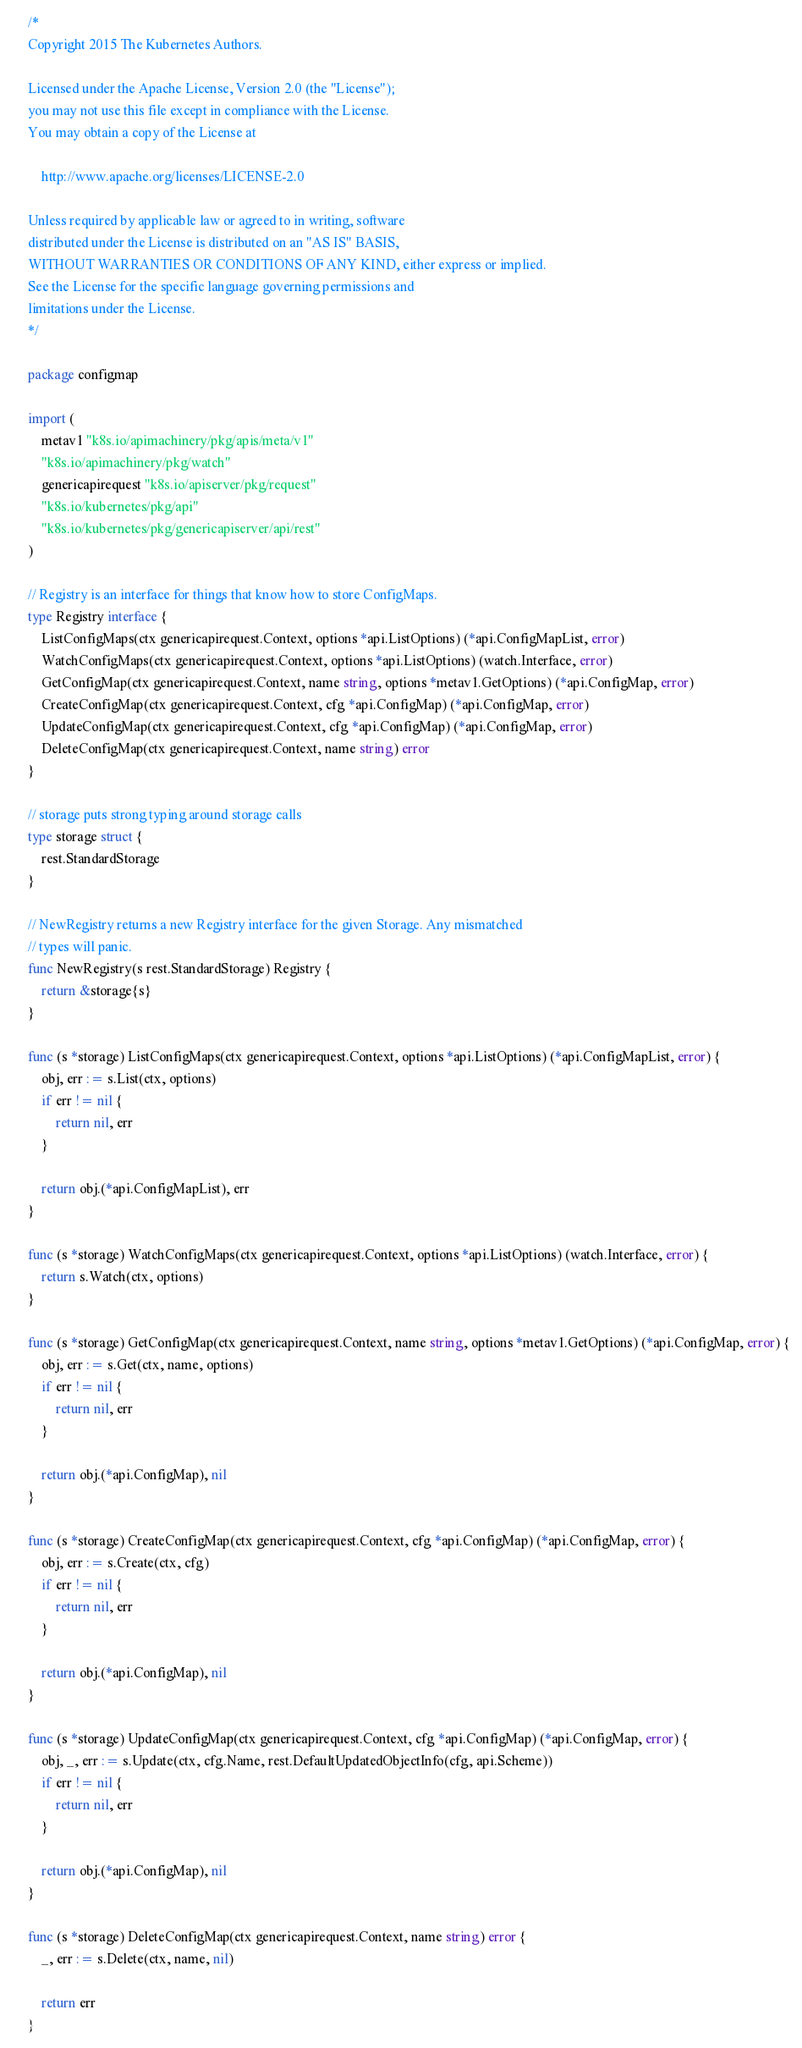Convert code to text. <code><loc_0><loc_0><loc_500><loc_500><_Go_>/*
Copyright 2015 The Kubernetes Authors.

Licensed under the Apache License, Version 2.0 (the "License");
you may not use this file except in compliance with the License.
You may obtain a copy of the License at

    http://www.apache.org/licenses/LICENSE-2.0

Unless required by applicable law or agreed to in writing, software
distributed under the License is distributed on an "AS IS" BASIS,
WITHOUT WARRANTIES OR CONDITIONS OF ANY KIND, either express or implied.
See the License for the specific language governing permissions and
limitations under the License.
*/

package configmap

import (
	metav1 "k8s.io/apimachinery/pkg/apis/meta/v1"
	"k8s.io/apimachinery/pkg/watch"
	genericapirequest "k8s.io/apiserver/pkg/request"
	"k8s.io/kubernetes/pkg/api"
	"k8s.io/kubernetes/pkg/genericapiserver/api/rest"
)

// Registry is an interface for things that know how to store ConfigMaps.
type Registry interface {
	ListConfigMaps(ctx genericapirequest.Context, options *api.ListOptions) (*api.ConfigMapList, error)
	WatchConfigMaps(ctx genericapirequest.Context, options *api.ListOptions) (watch.Interface, error)
	GetConfigMap(ctx genericapirequest.Context, name string, options *metav1.GetOptions) (*api.ConfigMap, error)
	CreateConfigMap(ctx genericapirequest.Context, cfg *api.ConfigMap) (*api.ConfigMap, error)
	UpdateConfigMap(ctx genericapirequest.Context, cfg *api.ConfigMap) (*api.ConfigMap, error)
	DeleteConfigMap(ctx genericapirequest.Context, name string) error
}

// storage puts strong typing around storage calls
type storage struct {
	rest.StandardStorage
}

// NewRegistry returns a new Registry interface for the given Storage. Any mismatched
// types will panic.
func NewRegistry(s rest.StandardStorage) Registry {
	return &storage{s}
}

func (s *storage) ListConfigMaps(ctx genericapirequest.Context, options *api.ListOptions) (*api.ConfigMapList, error) {
	obj, err := s.List(ctx, options)
	if err != nil {
		return nil, err
	}

	return obj.(*api.ConfigMapList), err
}

func (s *storage) WatchConfigMaps(ctx genericapirequest.Context, options *api.ListOptions) (watch.Interface, error) {
	return s.Watch(ctx, options)
}

func (s *storage) GetConfigMap(ctx genericapirequest.Context, name string, options *metav1.GetOptions) (*api.ConfigMap, error) {
	obj, err := s.Get(ctx, name, options)
	if err != nil {
		return nil, err
	}

	return obj.(*api.ConfigMap), nil
}

func (s *storage) CreateConfigMap(ctx genericapirequest.Context, cfg *api.ConfigMap) (*api.ConfigMap, error) {
	obj, err := s.Create(ctx, cfg)
	if err != nil {
		return nil, err
	}

	return obj.(*api.ConfigMap), nil
}

func (s *storage) UpdateConfigMap(ctx genericapirequest.Context, cfg *api.ConfigMap) (*api.ConfigMap, error) {
	obj, _, err := s.Update(ctx, cfg.Name, rest.DefaultUpdatedObjectInfo(cfg, api.Scheme))
	if err != nil {
		return nil, err
	}

	return obj.(*api.ConfigMap), nil
}

func (s *storage) DeleteConfigMap(ctx genericapirequest.Context, name string) error {
	_, err := s.Delete(ctx, name, nil)

	return err
}
</code> 